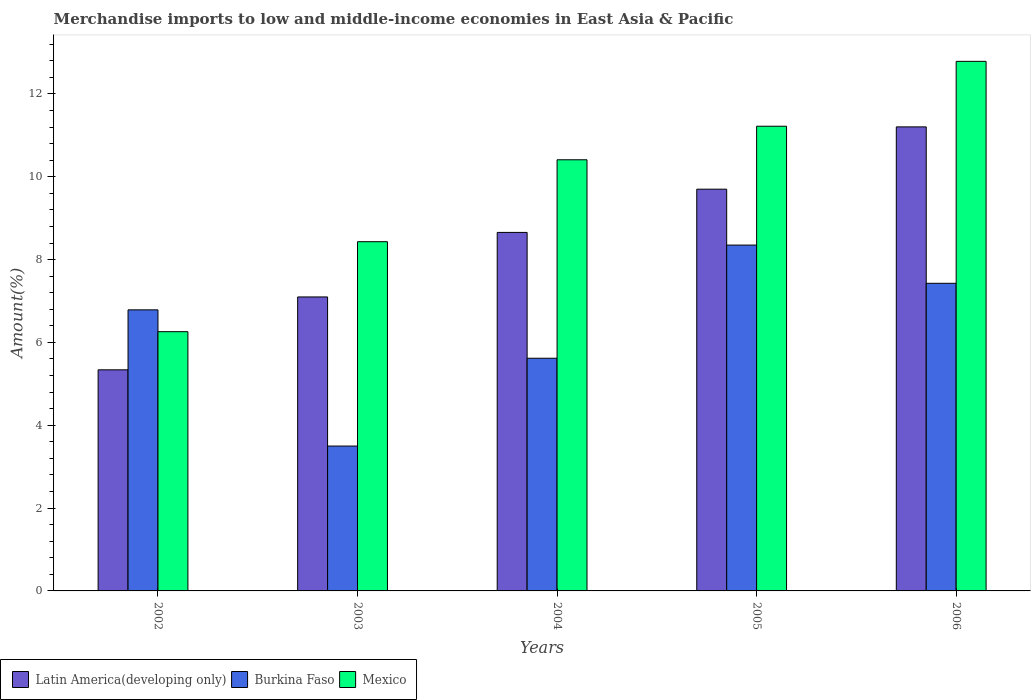How many different coloured bars are there?
Your response must be concise. 3. How many groups of bars are there?
Make the answer very short. 5. Are the number of bars on each tick of the X-axis equal?
Keep it short and to the point. Yes. How many bars are there on the 4th tick from the right?
Your answer should be very brief. 3. What is the percentage of amount earned from merchandise imports in Burkina Faso in 2004?
Your answer should be compact. 5.62. Across all years, what is the maximum percentage of amount earned from merchandise imports in Mexico?
Ensure brevity in your answer.  12.79. Across all years, what is the minimum percentage of amount earned from merchandise imports in Burkina Faso?
Give a very brief answer. 3.5. In which year was the percentage of amount earned from merchandise imports in Latin America(developing only) maximum?
Give a very brief answer. 2006. In which year was the percentage of amount earned from merchandise imports in Mexico minimum?
Your answer should be very brief. 2002. What is the total percentage of amount earned from merchandise imports in Mexico in the graph?
Your answer should be compact. 49.11. What is the difference between the percentage of amount earned from merchandise imports in Mexico in 2002 and that in 2003?
Offer a terse response. -2.17. What is the difference between the percentage of amount earned from merchandise imports in Burkina Faso in 2005 and the percentage of amount earned from merchandise imports in Mexico in 2003?
Provide a succinct answer. -0.08. What is the average percentage of amount earned from merchandise imports in Mexico per year?
Your response must be concise. 9.82. In the year 2006, what is the difference between the percentage of amount earned from merchandise imports in Mexico and percentage of amount earned from merchandise imports in Burkina Faso?
Give a very brief answer. 5.36. In how many years, is the percentage of amount earned from merchandise imports in Burkina Faso greater than 11.6 %?
Your response must be concise. 0. What is the ratio of the percentage of amount earned from merchandise imports in Burkina Faso in 2005 to that in 2006?
Make the answer very short. 1.12. Is the difference between the percentage of amount earned from merchandise imports in Mexico in 2004 and 2006 greater than the difference between the percentage of amount earned from merchandise imports in Burkina Faso in 2004 and 2006?
Your response must be concise. No. What is the difference between the highest and the second highest percentage of amount earned from merchandise imports in Mexico?
Your answer should be compact. 1.57. What is the difference between the highest and the lowest percentage of amount earned from merchandise imports in Latin America(developing only)?
Keep it short and to the point. 5.87. In how many years, is the percentage of amount earned from merchandise imports in Burkina Faso greater than the average percentage of amount earned from merchandise imports in Burkina Faso taken over all years?
Your answer should be very brief. 3. What does the 2nd bar from the left in 2006 represents?
Keep it short and to the point. Burkina Faso. What does the 1st bar from the right in 2002 represents?
Ensure brevity in your answer.  Mexico. How many bars are there?
Keep it short and to the point. 15. Are all the bars in the graph horizontal?
Make the answer very short. No. What is the difference between two consecutive major ticks on the Y-axis?
Your answer should be compact. 2. Are the values on the major ticks of Y-axis written in scientific E-notation?
Your answer should be very brief. No. Does the graph contain any zero values?
Keep it short and to the point. No. How many legend labels are there?
Provide a succinct answer. 3. What is the title of the graph?
Your answer should be very brief. Merchandise imports to low and middle-income economies in East Asia & Pacific. What is the label or title of the X-axis?
Provide a short and direct response. Years. What is the label or title of the Y-axis?
Your answer should be very brief. Amount(%). What is the Amount(%) of Latin America(developing only) in 2002?
Your answer should be compact. 5.34. What is the Amount(%) of Burkina Faso in 2002?
Make the answer very short. 6.79. What is the Amount(%) of Mexico in 2002?
Keep it short and to the point. 6.26. What is the Amount(%) of Latin America(developing only) in 2003?
Make the answer very short. 7.1. What is the Amount(%) in Burkina Faso in 2003?
Offer a very short reply. 3.5. What is the Amount(%) of Mexico in 2003?
Give a very brief answer. 8.43. What is the Amount(%) of Latin America(developing only) in 2004?
Keep it short and to the point. 8.66. What is the Amount(%) of Burkina Faso in 2004?
Offer a very short reply. 5.62. What is the Amount(%) of Mexico in 2004?
Offer a very short reply. 10.41. What is the Amount(%) in Latin America(developing only) in 2005?
Offer a terse response. 9.7. What is the Amount(%) in Burkina Faso in 2005?
Provide a succinct answer. 8.35. What is the Amount(%) of Mexico in 2005?
Provide a succinct answer. 11.22. What is the Amount(%) of Latin America(developing only) in 2006?
Provide a succinct answer. 11.2. What is the Amount(%) of Burkina Faso in 2006?
Keep it short and to the point. 7.43. What is the Amount(%) of Mexico in 2006?
Ensure brevity in your answer.  12.79. Across all years, what is the maximum Amount(%) of Latin America(developing only)?
Provide a short and direct response. 11.2. Across all years, what is the maximum Amount(%) of Burkina Faso?
Provide a short and direct response. 8.35. Across all years, what is the maximum Amount(%) in Mexico?
Your response must be concise. 12.79. Across all years, what is the minimum Amount(%) in Latin America(developing only)?
Provide a short and direct response. 5.34. Across all years, what is the minimum Amount(%) in Burkina Faso?
Your response must be concise. 3.5. Across all years, what is the minimum Amount(%) of Mexico?
Your answer should be very brief. 6.26. What is the total Amount(%) in Latin America(developing only) in the graph?
Your response must be concise. 42. What is the total Amount(%) in Burkina Faso in the graph?
Ensure brevity in your answer.  31.68. What is the total Amount(%) in Mexico in the graph?
Your answer should be very brief. 49.11. What is the difference between the Amount(%) in Latin America(developing only) in 2002 and that in 2003?
Provide a short and direct response. -1.76. What is the difference between the Amount(%) of Burkina Faso in 2002 and that in 2003?
Make the answer very short. 3.29. What is the difference between the Amount(%) of Mexico in 2002 and that in 2003?
Provide a short and direct response. -2.17. What is the difference between the Amount(%) of Latin America(developing only) in 2002 and that in 2004?
Keep it short and to the point. -3.32. What is the difference between the Amount(%) of Burkina Faso in 2002 and that in 2004?
Your answer should be compact. 1.17. What is the difference between the Amount(%) of Mexico in 2002 and that in 2004?
Make the answer very short. -4.15. What is the difference between the Amount(%) of Latin America(developing only) in 2002 and that in 2005?
Give a very brief answer. -4.36. What is the difference between the Amount(%) of Burkina Faso in 2002 and that in 2005?
Your answer should be compact. -1.56. What is the difference between the Amount(%) of Mexico in 2002 and that in 2005?
Your response must be concise. -4.96. What is the difference between the Amount(%) of Latin America(developing only) in 2002 and that in 2006?
Give a very brief answer. -5.87. What is the difference between the Amount(%) in Burkina Faso in 2002 and that in 2006?
Provide a short and direct response. -0.64. What is the difference between the Amount(%) in Mexico in 2002 and that in 2006?
Offer a very short reply. -6.53. What is the difference between the Amount(%) of Latin America(developing only) in 2003 and that in 2004?
Offer a very short reply. -1.56. What is the difference between the Amount(%) in Burkina Faso in 2003 and that in 2004?
Offer a terse response. -2.12. What is the difference between the Amount(%) in Mexico in 2003 and that in 2004?
Your response must be concise. -1.98. What is the difference between the Amount(%) in Latin America(developing only) in 2003 and that in 2005?
Make the answer very short. -2.6. What is the difference between the Amount(%) of Burkina Faso in 2003 and that in 2005?
Your answer should be compact. -4.85. What is the difference between the Amount(%) in Mexico in 2003 and that in 2005?
Offer a very short reply. -2.79. What is the difference between the Amount(%) in Latin America(developing only) in 2003 and that in 2006?
Offer a terse response. -4.11. What is the difference between the Amount(%) in Burkina Faso in 2003 and that in 2006?
Make the answer very short. -3.93. What is the difference between the Amount(%) of Mexico in 2003 and that in 2006?
Your answer should be very brief. -4.35. What is the difference between the Amount(%) of Latin America(developing only) in 2004 and that in 2005?
Provide a succinct answer. -1.04. What is the difference between the Amount(%) in Burkina Faso in 2004 and that in 2005?
Ensure brevity in your answer.  -2.73. What is the difference between the Amount(%) of Mexico in 2004 and that in 2005?
Offer a terse response. -0.81. What is the difference between the Amount(%) of Latin America(developing only) in 2004 and that in 2006?
Your answer should be very brief. -2.55. What is the difference between the Amount(%) in Burkina Faso in 2004 and that in 2006?
Make the answer very short. -1.81. What is the difference between the Amount(%) in Mexico in 2004 and that in 2006?
Provide a succinct answer. -2.38. What is the difference between the Amount(%) in Latin America(developing only) in 2005 and that in 2006?
Give a very brief answer. -1.5. What is the difference between the Amount(%) of Burkina Faso in 2005 and that in 2006?
Offer a terse response. 0.92. What is the difference between the Amount(%) of Mexico in 2005 and that in 2006?
Give a very brief answer. -1.57. What is the difference between the Amount(%) in Latin America(developing only) in 2002 and the Amount(%) in Burkina Faso in 2003?
Ensure brevity in your answer.  1.84. What is the difference between the Amount(%) of Latin America(developing only) in 2002 and the Amount(%) of Mexico in 2003?
Offer a terse response. -3.09. What is the difference between the Amount(%) of Burkina Faso in 2002 and the Amount(%) of Mexico in 2003?
Your answer should be compact. -1.65. What is the difference between the Amount(%) in Latin America(developing only) in 2002 and the Amount(%) in Burkina Faso in 2004?
Make the answer very short. -0.28. What is the difference between the Amount(%) in Latin America(developing only) in 2002 and the Amount(%) in Mexico in 2004?
Offer a terse response. -5.07. What is the difference between the Amount(%) in Burkina Faso in 2002 and the Amount(%) in Mexico in 2004?
Provide a succinct answer. -3.62. What is the difference between the Amount(%) of Latin America(developing only) in 2002 and the Amount(%) of Burkina Faso in 2005?
Provide a succinct answer. -3.01. What is the difference between the Amount(%) in Latin America(developing only) in 2002 and the Amount(%) in Mexico in 2005?
Your answer should be compact. -5.88. What is the difference between the Amount(%) of Burkina Faso in 2002 and the Amount(%) of Mexico in 2005?
Your answer should be compact. -4.43. What is the difference between the Amount(%) of Latin America(developing only) in 2002 and the Amount(%) of Burkina Faso in 2006?
Ensure brevity in your answer.  -2.09. What is the difference between the Amount(%) of Latin America(developing only) in 2002 and the Amount(%) of Mexico in 2006?
Give a very brief answer. -7.45. What is the difference between the Amount(%) in Burkina Faso in 2002 and the Amount(%) in Mexico in 2006?
Provide a short and direct response. -6. What is the difference between the Amount(%) in Latin America(developing only) in 2003 and the Amount(%) in Burkina Faso in 2004?
Ensure brevity in your answer.  1.48. What is the difference between the Amount(%) in Latin America(developing only) in 2003 and the Amount(%) in Mexico in 2004?
Your response must be concise. -3.31. What is the difference between the Amount(%) in Burkina Faso in 2003 and the Amount(%) in Mexico in 2004?
Provide a short and direct response. -6.91. What is the difference between the Amount(%) of Latin America(developing only) in 2003 and the Amount(%) of Burkina Faso in 2005?
Provide a succinct answer. -1.25. What is the difference between the Amount(%) in Latin America(developing only) in 2003 and the Amount(%) in Mexico in 2005?
Give a very brief answer. -4.12. What is the difference between the Amount(%) of Burkina Faso in 2003 and the Amount(%) of Mexico in 2005?
Give a very brief answer. -7.72. What is the difference between the Amount(%) in Latin America(developing only) in 2003 and the Amount(%) in Burkina Faso in 2006?
Make the answer very short. -0.33. What is the difference between the Amount(%) of Latin America(developing only) in 2003 and the Amount(%) of Mexico in 2006?
Your answer should be compact. -5.69. What is the difference between the Amount(%) of Burkina Faso in 2003 and the Amount(%) of Mexico in 2006?
Offer a very short reply. -9.29. What is the difference between the Amount(%) of Latin America(developing only) in 2004 and the Amount(%) of Burkina Faso in 2005?
Make the answer very short. 0.31. What is the difference between the Amount(%) in Latin America(developing only) in 2004 and the Amount(%) in Mexico in 2005?
Offer a terse response. -2.56. What is the difference between the Amount(%) in Burkina Faso in 2004 and the Amount(%) in Mexico in 2005?
Make the answer very short. -5.6. What is the difference between the Amount(%) of Latin America(developing only) in 2004 and the Amount(%) of Burkina Faso in 2006?
Provide a short and direct response. 1.23. What is the difference between the Amount(%) in Latin America(developing only) in 2004 and the Amount(%) in Mexico in 2006?
Your answer should be compact. -4.13. What is the difference between the Amount(%) in Burkina Faso in 2004 and the Amount(%) in Mexico in 2006?
Ensure brevity in your answer.  -7.17. What is the difference between the Amount(%) in Latin America(developing only) in 2005 and the Amount(%) in Burkina Faso in 2006?
Make the answer very short. 2.27. What is the difference between the Amount(%) in Latin America(developing only) in 2005 and the Amount(%) in Mexico in 2006?
Offer a very short reply. -3.09. What is the difference between the Amount(%) in Burkina Faso in 2005 and the Amount(%) in Mexico in 2006?
Make the answer very short. -4.44. What is the average Amount(%) of Latin America(developing only) per year?
Keep it short and to the point. 8.4. What is the average Amount(%) in Burkina Faso per year?
Give a very brief answer. 6.34. What is the average Amount(%) of Mexico per year?
Provide a succinct answer. 9.82. In the year 2002, what is the difference between the Amount(%) in Latin America(developing only) and Amount(%) in Burkina Faso?
Make the answer very short. -1.45. In the year 2002, what is the difference between the Amount(%) of Latin America(developing only) and Amount(%) of Mexico?
Offer a very short reply. -0.92. In the year 2002, what is the difference between the Amount(%) in Burkina Faso and Amount(%) in Mexico?
Your answer should be very brief. 0.53. In the year 2003, what is the difference between the Amount(%) of Latin America(developing only) and Amount(%) of Burkina Faso?
Your answer should be compact. 3.6. In the year 2003, what is the difference between the Amount(%) of Latin America(developing only) and Amount(%) of Mexico?
Your answer should be compact. -1.33. In the year 2003, what is the difference between the Amount(%) in Burkina Faso and Amount(%) in Mexico?
Provide a short and direct response. -4.93. In the year 2004, what is the difference between the Amount(%) in Latin America(developing only) and Amount(%) in Burkina Faso?
Ensure brevity in your answer.  3.04. In the year 2004, what is the difference between the Amount(%) in Latin America(developing only) and Amount(%) in Mexico?
Your answer should be very brief. -1.75. In the year 2004, what is the difference between the Amount(%) in Burkina Faso and Amount(%) in Mexico?
Offer a very short reply. -4.79. In the year 2005, what is the difference between the Amount(%) of Latin America(developing only) and Amount(%) of Burkina Faso?
Your response must be concise. 1.35. In the year 2005, what is the difference between the Amount(%) of Latin America(developing only) and Amount(%) of Mexico?
Your answer should be compact. -1.52. In the year 2005, what is the difference between the Amount(%) of Burkina Faso and Amount(%) of Mexico?
Provide a succinct answer. -2.87. In the year 2006, what is the difference between the Amount(%) in Latin America(developing only) and Amount(%) in Burkina Faso?
Your answer should be very brief. 3.78. In the year 2006, what is the difference between the Amount(%) in Latin America(developing only) and Amount(%) in Mexico?
Offer a very short reply. -1.58. In the year 2006, what is the difference between the Amount(%) in Burkina Faso and Amount(%) in Mexico?
Offer a very short reply. -5.36. What is the ratio of the Amount(%) of Latin America(developing only) in 2002 to that in 2003?
Your answer should be very brief. 0.75. What is the ratio of the Amount(%) in Burkina Faso in 2002 to that in 2003?
Give a very brief answer. 1.94. What is the ratio of the Amount(%) of Mexico in 2002 to that in 2003?
Make the answer very short. 0.74. What is the ratio of the Amount(%) in Latin America(developing only) in 2002 to that in 2004?
Make the answer very short. 0.62. What is the ratio of the Amount(%) in Burkina Faso in 2002 to that in 2004?
Give a very brief answer. 1.21. What is the ratio of the Amount(%) of Mexico in 2002 to that in 2004?
Provide a succinct answer. 0.6. What is the ratio of the Amount(%) in Latin America(developing only) in 2002 to that in 2005?
Make the answer very short. 0.55. What is the ratio of the Amount(%) in Burkina Faso in 2002 to that in 2005?
Your response must be concise. 0.81. What is the ratio of the Amount(%) in Mexico in 2002 to that in 2005?
Make the answer very short. 0.56. What is the ratio of the Amount(%) of Latin America(developing only) in 2002 to that in 2006?
Your answer should be very brief. 0.48. What is the ratio of the Amount(%) in Burkina Faso in 2002 to that in 2006?
Offer a terse response. 0.91. What is the ratio of the Amount(%) in Mexico in 2002 to that in 2006?
Give a very brief answer. 0.49. What is the ratio of the Amount(%) of Latin America(developing only) in 2003 to that in 2004?
Your answer should be very brief. 0.82. What is the ratio of the Amount(%) of Burkina Faso in 2003 to that in 2004?
Your response must be concise. 0.62. What is the ratio of the Amount(%) of Mexico in 2003 to that in 2004?
Ensure brevity in your answer.  0.81. What is the ratio of the Amount(%) in Latin America(developing only) in 2003 to that in 2005?
Keep it short and to the point. 0.73. What is the ratio of the Amount(%) in Burkina Faso in 2003 to that in 2005?
Provide a short and direct response. 0.42. What is the ratio of the Amount(%) of Mexico in 2003 to that in 2005?
Your response must be concise. 0.75. What is the ratio of the Amount(%) of Latin America(developing only) in 2003 to that in 2006?
Your answer should be compact. 0.63. What is the ratio of the Amount(%) in Burkina Faso in 2003 to that in 2006?
Provide a short and direct response. 0.47. What is the ratio of the Amount(%) in Mexico in 2003 to that in 2006?
Provide a succinct answer. 0.66. What is the ratio of the Amount(%) in Latin America(developing only) in 2004 to that in 2005?
Offer a terse response. 0.89. What is the ratio of the Amount(%) in Burkina Faso in 2004 to that in 2005?
Keep it short and to the point. 0.67. What is the ratio of the Amount(%) in Mexico in 2004 to that in 2005?
Keep it short and to the point. 0.93. What is the ratio of the Amount(%) in Latin America(developing only) in 2004 to that in 2006?
Offer a terse response. 0.77. What is the ratio of the Amount(%) in Burkina Faso in 2004 to that in 2006?
Offer a terse response. 0.76. What is the ratio of the Amount(%) of Mexico in 2004 to that in 2006?
Offer a very short reply. 0.81. What is the ratio of the Amount(%) of Latin America(developing only) in 2005 to that in 2006?
Provide a short and direct response. 0.87. What is the ratio of the Amount(%) of Burkina Faso in 2005 to that in 2006?
Offer a very short reply. 1.12. What is the ratio of the Amount(%) of Mexico in 2005 to that in 2006?
Provide a short and direct response. 0.88. What is the difference between the highest and the second highest Amount(%) in Latin America(developing only)?
Offer a very short reply. 1.5. What is the difference between the highest and the second highest Amount(%) in Mexico?
Your response must be concise. 1.57. What is the difference between the highest and the lowest Amount(%) of Latin America(developing only)?
Make the answer very short. 5.87. What is the difference between the highest and the lowest Amount(%) in Burkina Faso?
Keep it short and to the point. 4.85. What is the difference between the highest and the lowest Amount(%) in Mexico?
Your answer should be very brief. 6.53. 